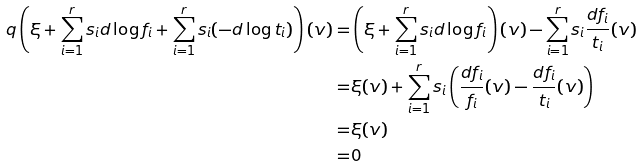<formula> <loc_0><loc_0><loc_500><loc_500>q \left ( \xi + \sum _ { i = 1 } ^ { r } s _ { i } d \log f _ { i } + \sum _ { i = 1 } ^ { r } s _ { i } ( - d \log t _ { i } ) \right ) ( v ) = & \left ( \xi + \sum _ { i = 1 } ^ { r } s _ { i } d \log f _ { i } \right ) ( v ) - \sum _ { i = 1 } ^ { r } s _ { i } \frac { d f _ { i } } { t _ { i } } ( v ) \\ = & \xi ( v ) + \sum _ { i = 1 } ^ { r } s _ { i } \left ( \frac { d f _ { i } } { f _ { i } } ( v ) - \frac { d f _ { i } } { t _ { i } } ( v ) \right ) \\ = & \xi ( v ) \\ = & 0</formula> 